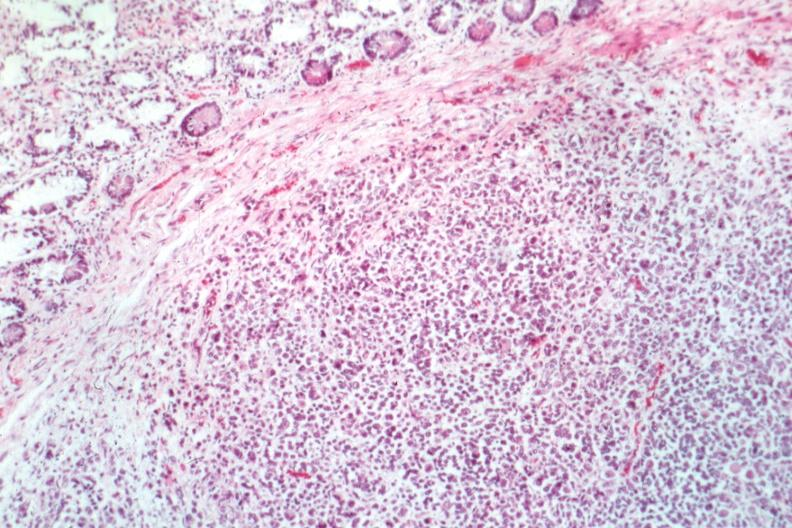what does this image show?
Answer the question using a single word or phrase. Good example can tell even at what the tumor is 